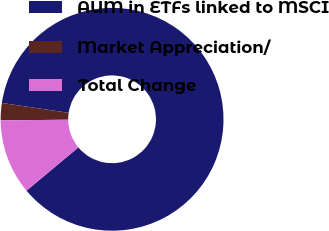<chart> <loc_0><loc_0><loc_500><loc_500><pie_chart><fcel>AUM in ETFs linked to MSCI<fcel>Market Appreciation/<fcel>Total Change<nl><fcel>86.59%<fcel>2.5%<fcel>10.91%<nl></chart> 